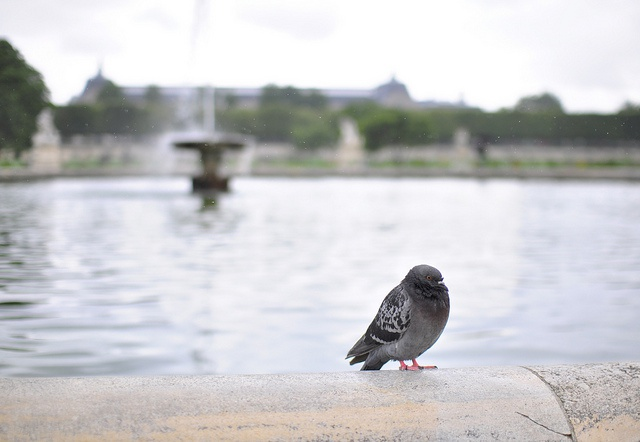Describe the objects in this image and their specific colors. I can see a bird in lavender, gray, and black tones in this image. 